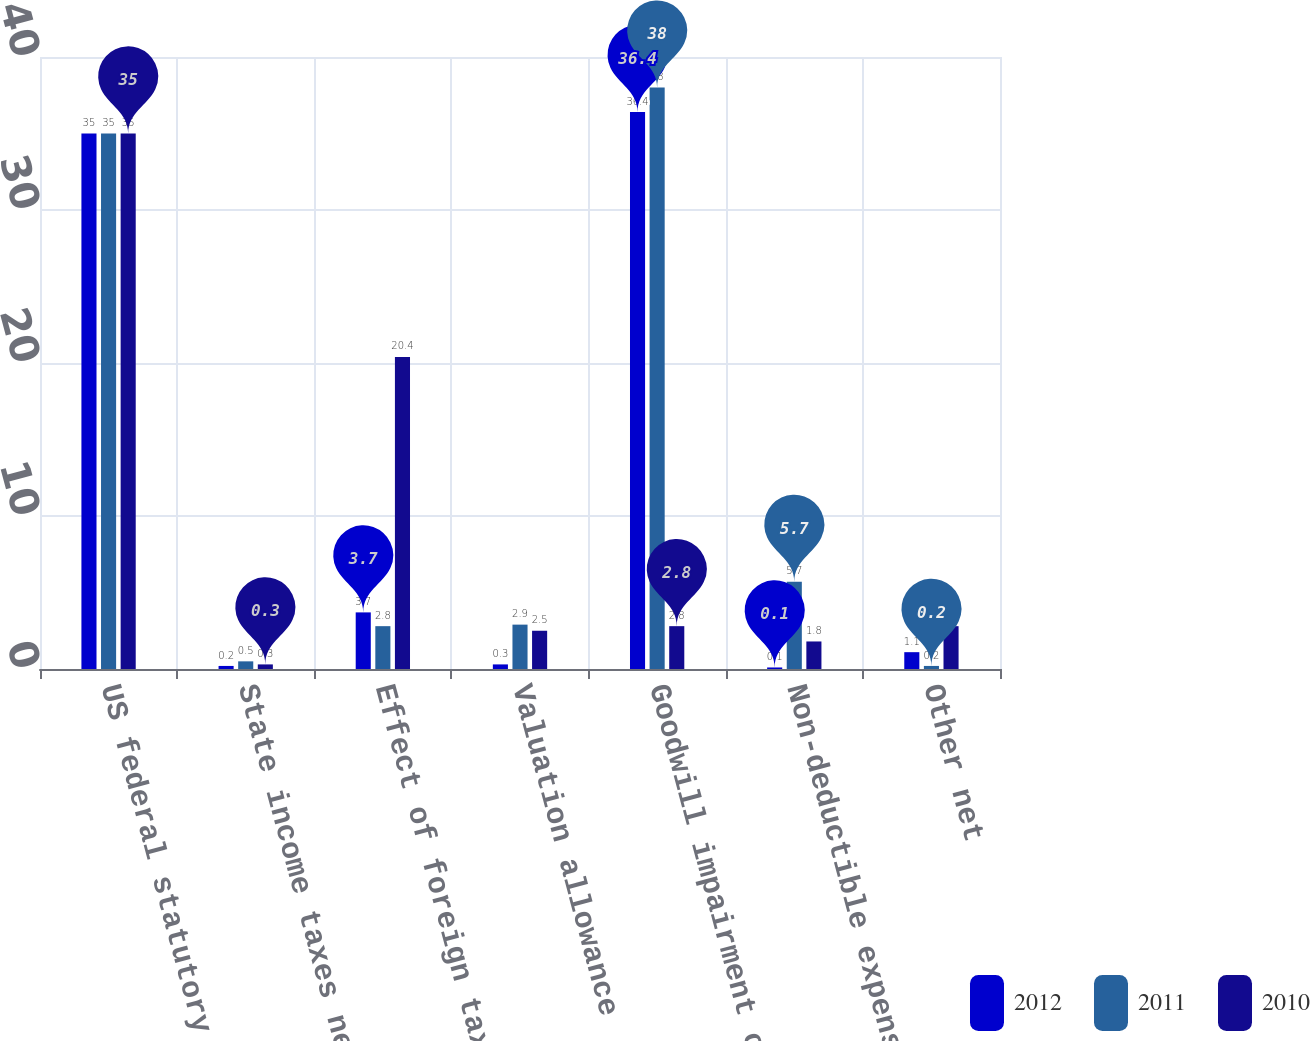Convert chart. <chart><loc_0><loc_0><loc_500><loc_500><stacked_bar_chart><ecel><fcel>US federal statutory income<fcel>State income taxes net of<fcel>Effect of foreign taxes<fcel>Valuation allowance<fcel>Goodwill impairment charges<fcel>Non-deductible expenses<fcel>Other net<nl><fcel>2012<fcel>35<fcel>0.2<fcel>3.7<fcel>0.3<fcel>36.4<fcel>0.1<fcel>1.1<nl><fcel>2011<fcel>35<fcel>0.5<fcel>2.8<fcel>2.9<fcel>38<fcel>5.7<fcel>0.2<nl><fcel>2010<fcel>35<fcel>0.3<fcel>20.4<fcel>2.5<fcel>2.8<fcel>1.8<fcel>2.8<nl></chart> 